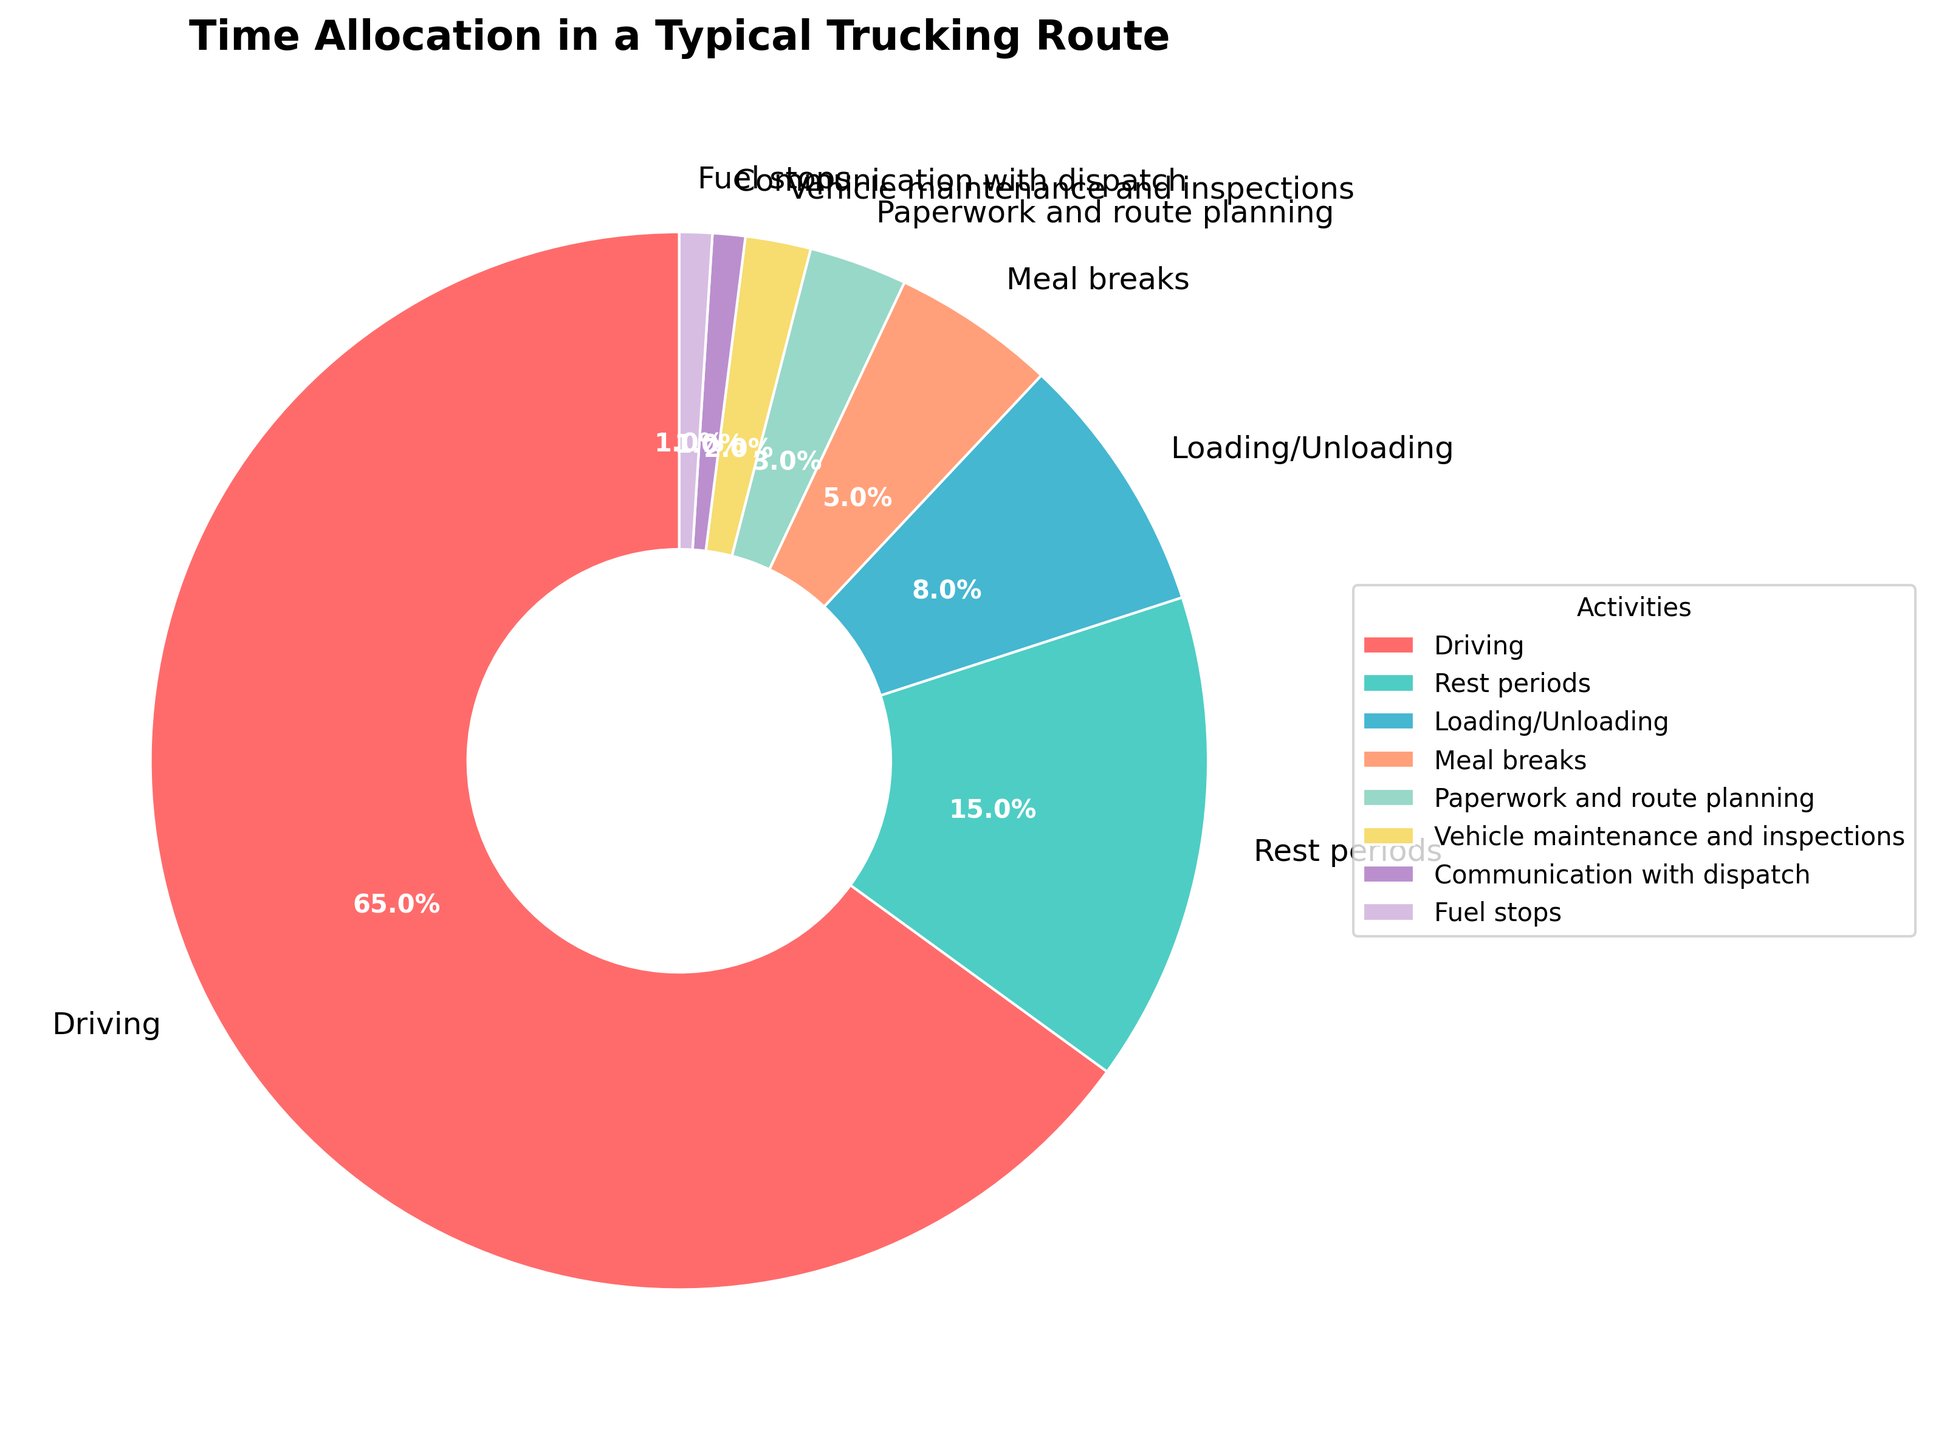what percentage of time is spent on driving? To find the percentage of time spent on driving, we refer to the pie chart where "Driving" is labeled. The value next to it represents the percentage.
Answer: 65% which activity has the smallest percentage of time allocated? Examine all the labels and associated percentages in the pie chart to identify the one with the smallest value, which is "Communication with dispatch" at 1%.
Answer: Communication with dispatch what is the combined percentage of time spent on meal breaks and rest periods? Locate the percentages for "Meal breaks" (5%) and "Rest periods" (15%) in the pie chart. Add these two values together: 5% + 15% = 20%.
Answer: 20% are more time spent on loading/unloading or on paperwork and route planning? Compare the percentage for "Loading/Unloading" (8%) with the percentage for "Paperwork and route planning" (3%) in the pie chart. Since 8% is greater than 3%, more time is spent on Loading/Unloading.
Answer: Loading/Unloading what is the difference in percentage between driving and vehicle maintenance and inspections? Locate the percentages for "Driving" (65%) and "Vehicle maintenance and inspections" (2%). Subtract the smaller percentage from the larger one: 65% - 2% = 63%.
Answer: 63% if time for vehicle maintenance and inspections were doubled, what would this new percentage be? The current percentage for "Vehicle maintenance and inspections" is 2%. Doubling it means multiplying it by 2, so 2% * 2 = 4%.
Answer: 4% how many activities have a percentage greater than 10%? By examining the pie chart, the activities "Driving" (65%) and "Rest periods" (15%) have percentages greater than 10%. Therefore, there are 2 activities.
Answer: 2 which activities have a total combined percentage of less than 10%? Identify activities with smaller percentages: "Vehicle maintenance and inspections" (2%), "Communication with dispatch" (1%), and "Fuel stops" (1%). Adding these: 2% + 1% + 1% = 4%, which is less than 10%. These activities combined have less than 10%.
Answer: Vehicle maintenance and inspections, Communication with dispatch, Fuel stops 